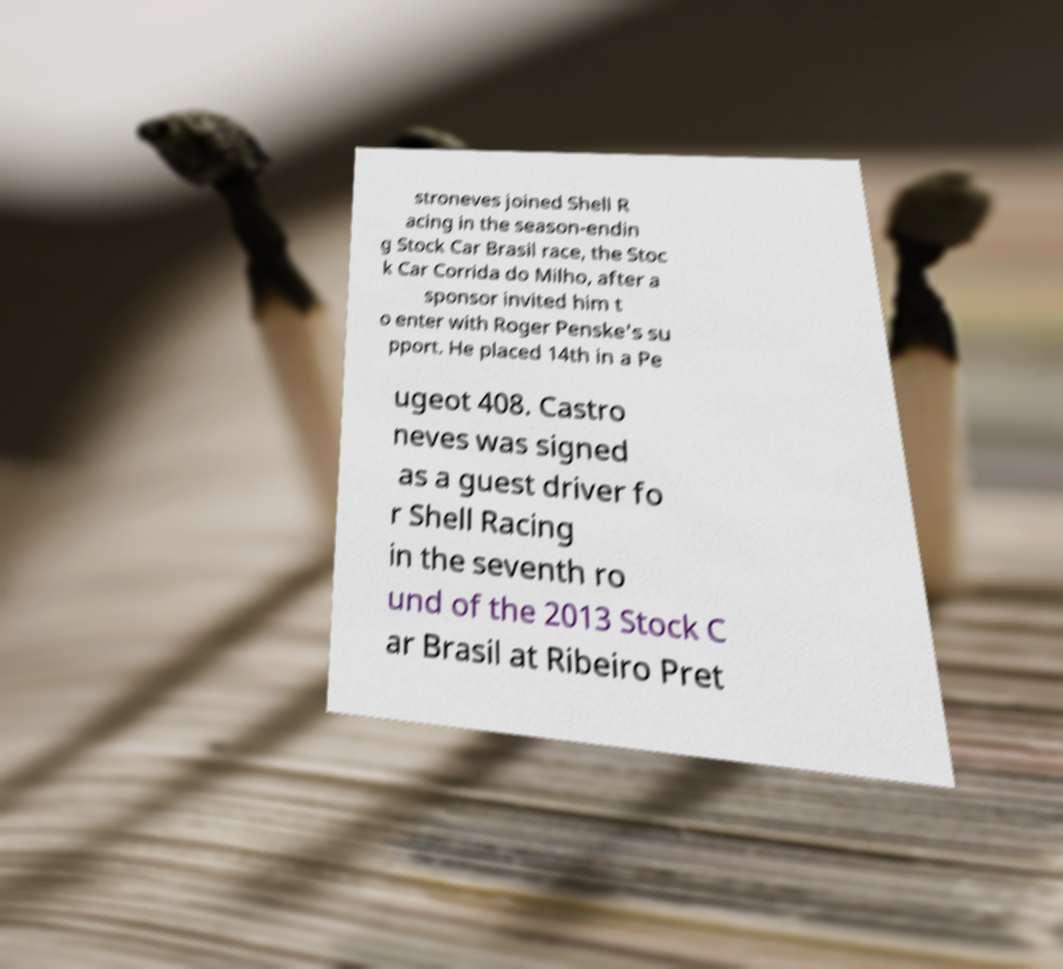Could you extract and type out the text from this image? stroneves joined Shell R acing in the season-endin g Stock Car Brasil race, the Stoc k Car Corrida do Milho, after a sponsor invited him t o enter with Roger Penske's su pport. He placed 14th in a Pe ugeot 408. Castro neves was signed as a guest driver fo r Shell Racing in the seventh ro und of the 2013 Stock C ar Brasil at Ribeiro Pret 